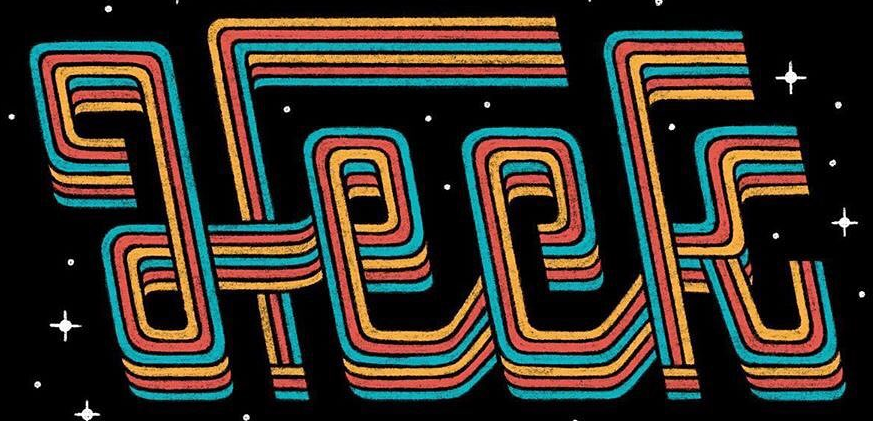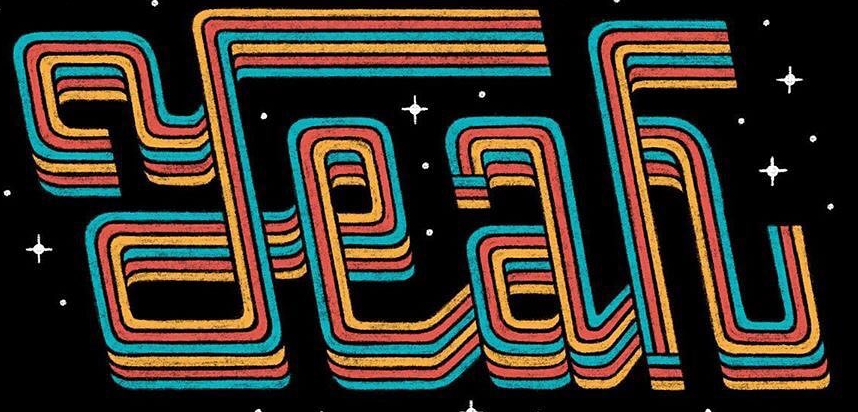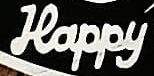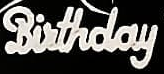What text is displayed in these images sequentially, separated by a semicolon? Heck; Yeah; Happy; Birthday 